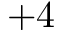Convert formula to latex. <formula><loc_0><loc_0><loc_500><loc_500>+ 4</formula> 